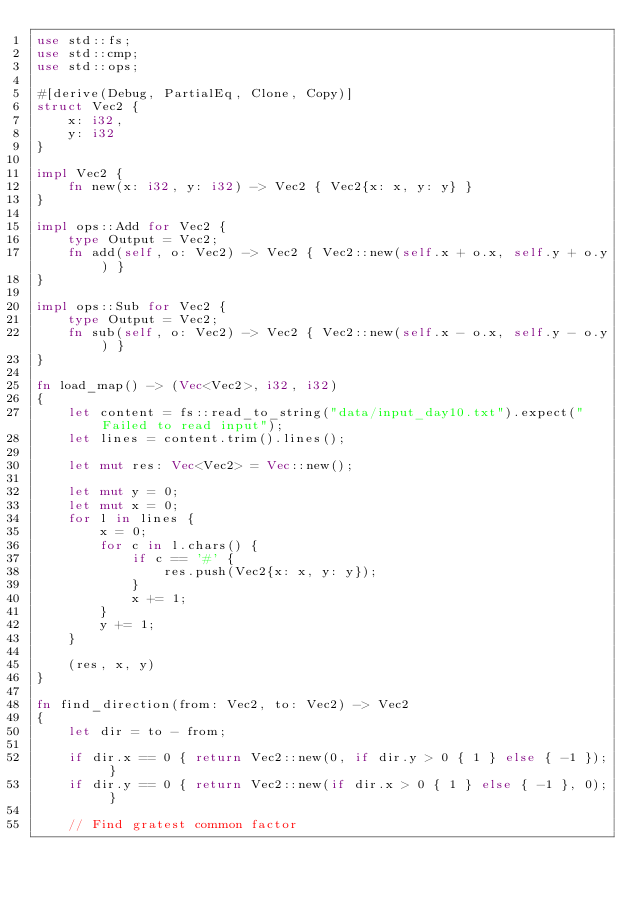Convert code to text. <code><loc_0><loc_0><loc_500><loc_500><_Rust_>use std::fs;
use std::cmp;
use std::ops;

#[derive(Debug, PartialEq, Clone, Copy)]
struct Vec2 {
    x: i32,
    y: i32
}

impl Vec2 {
    fn new(x: i32, y: i32) -> Vec2 { Vec2{x: x, y: y} }
}

impl ops::Add for Vec2 {
    type Output = Vec2;
    fn add(self, o: Vec2) -> Vec2 { Vec2::new(self.x + o.x, self.y + o.y) }
}

impl ops::Sub for Vec2 {
    type Output = Vec2;
    fn sub(self, o: Vec2) -> Vec2 { Vec2::new(self.x - o.x, self.y - o.y) }
}

fn load_map() -> (Vec<Vec2>, i32, i32)
{
    let content = fs::read_to_string("data/input_day10.txt").expect("Failed to read input");
    let lines = content.trim().lines();

    let mut res: Vec<Vec2> = Vec::new();

    let mut y = 0;
    let mut x = 0;
    for l in lines {
        x = 0;
        for c in l.chars() {
            if c == '#' {
                res.push(Vec2{x: x, y: y});
            }
            x += 1;
        }
        y += 1;
    }

    (res, x, y)
}

fn find_direction(from: Vec2, to: Vec2) -> Vec2
{
    let dir = to - from;

    if dir.x == 0 { return Vec2::new(0, if dir.y > 0 { 1 } else { -1 }); }
    if dir.y == 0 { return Vec2::new(if dir.x > 0 { 1 } else { -1 }, 0); }

    // Find gratest common factor</code> 